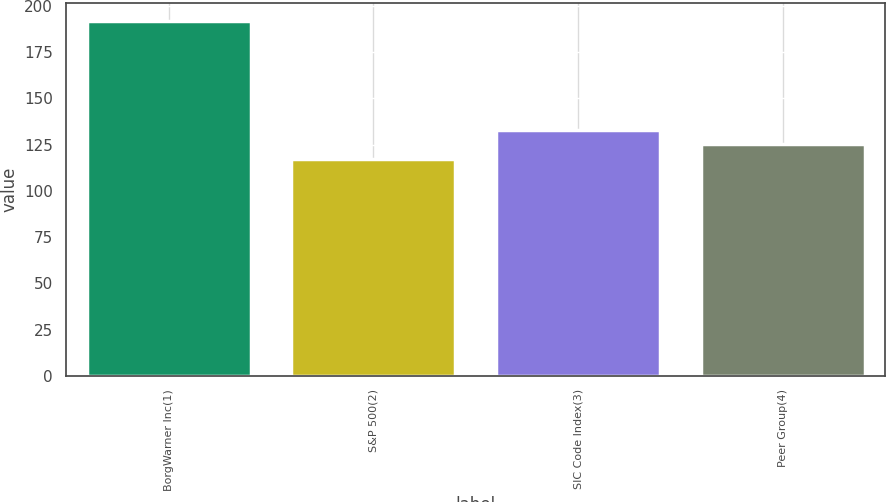Convert chart. <chart><loc_0><loc_0><loc_500><loc_500><bar_chart><fcel>BorgWarner Inc(1)<fcel>S&P 500(2)<fcel>SIC Code Index(3)<fcel>Peer Group(4)<nl><fcel>191.87<fcel>117.49<fcel>132.97<fcel>125.53<nl></chart> 